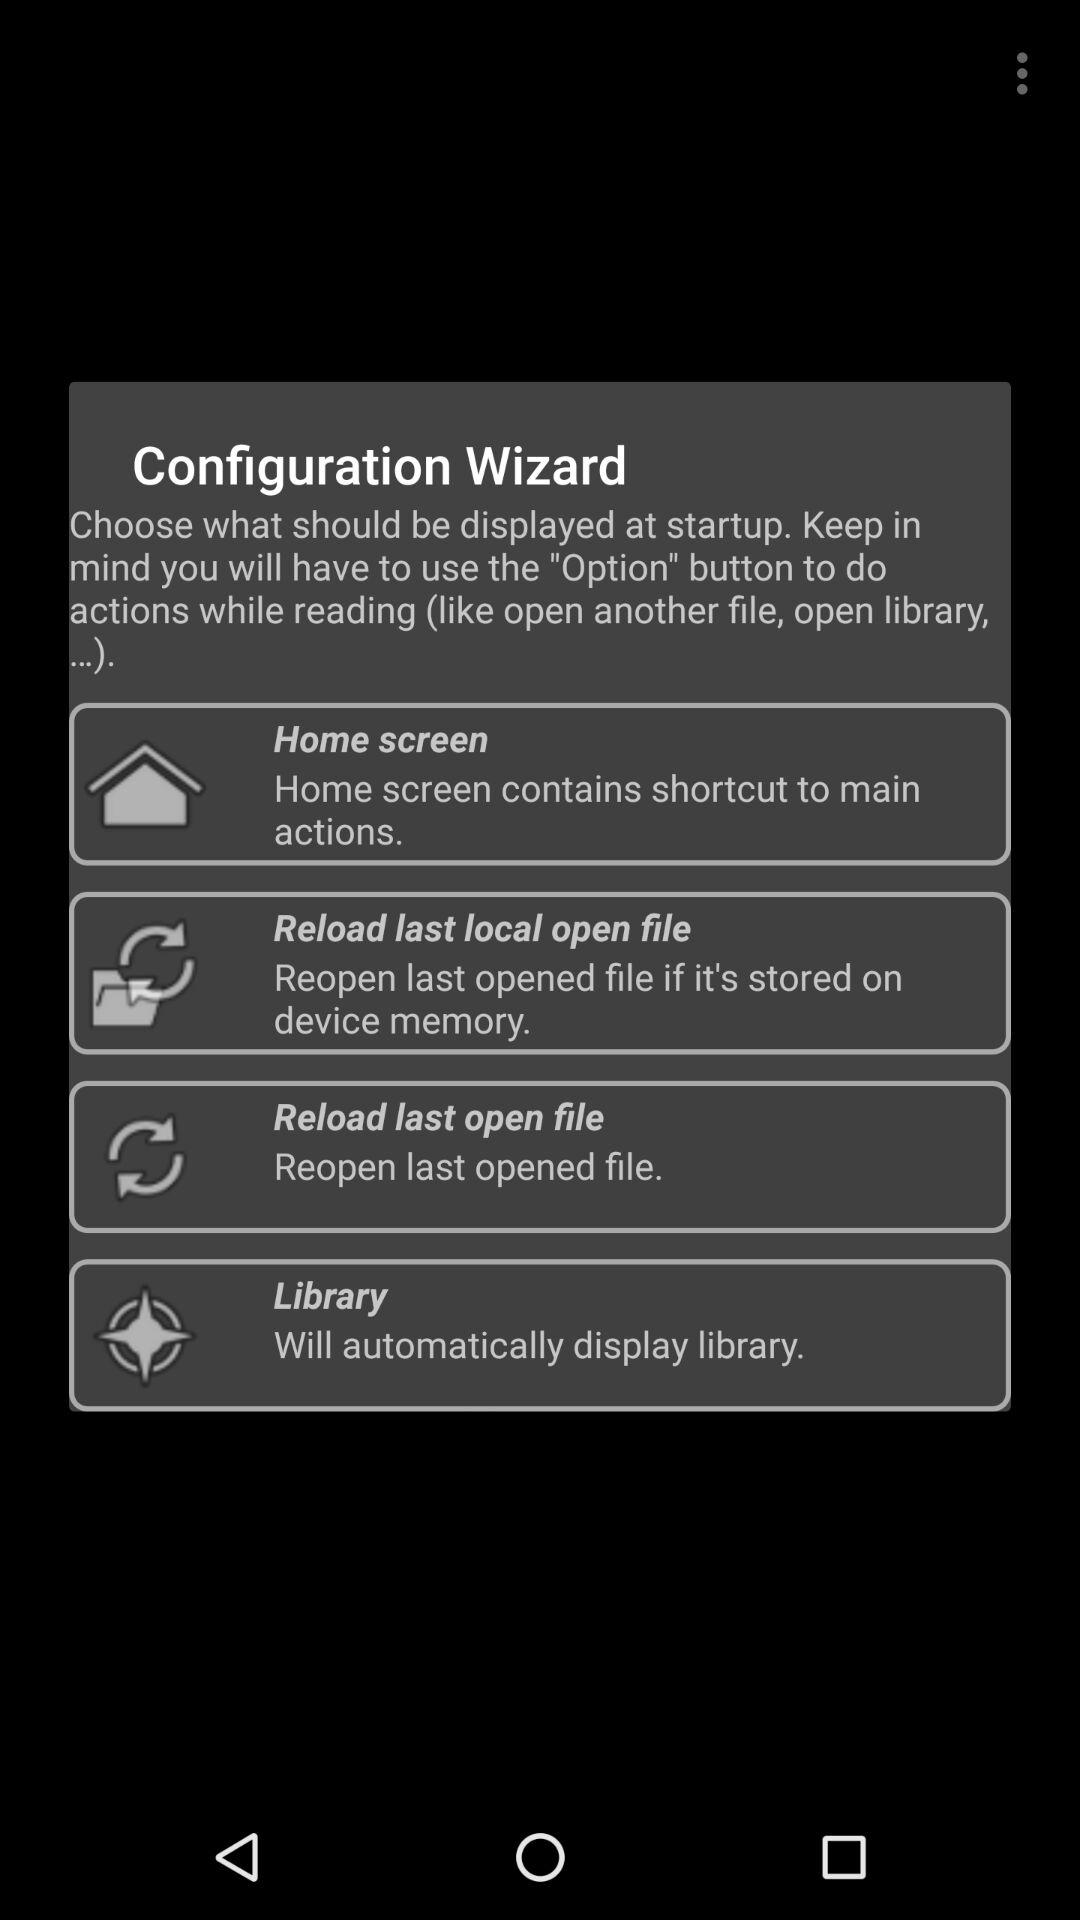How many options show a file being opened?
Answer the question using a single word or phrase. 2 